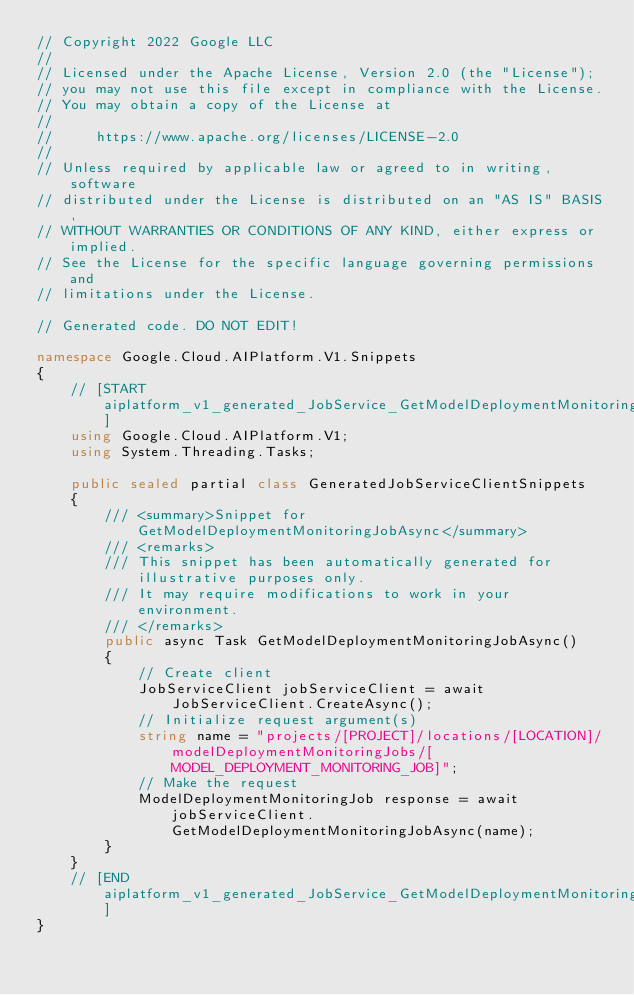Convert code to text. <code><loc_0><loc_0><loc_500><loc_500><_C#_>// Copyright 2022 Google LLC
//
// Licensed under the Apache License, Version 2.0 (the "License");
// you may not use this file except in compliance with the License.
// You may obtain a copy of the License at
//
//     https://www.apache.org/licenses/LICENSE-2.0
//
// Unless required by applicable law or agreed to in writing, software
// distributed under the License is distributed on an "AS IS" BASIS,
// WITHOUT WARRANTIES OR CONDITIONS OF ANY KIND, either express or implied.
// See the License for the specific language governing permissions and
// limitations under the License.

// Generated code. DO NOT EDIT!

namespace Google.Cloud.AIPlatform.V1.Snippets
{
    // [START aiplatform_v1_generated_JobService_GetModelDeploymentMonitoringJob_async_flattened]
    using Google.Cloud.AIPlatform.V1;
    using System.Threading.Tasks;

    public sealed partial class GeneratedJobServiceClientSnippets
    {
        /// <summary>Snippet for GetModelDeploymentMonitoringJobAsync</summary>
        /// <remarks>
        /// This snippet has been automatically generated for illustrative purposes only.
        /// It may require modifications to work in your environment.
        /// </remarks>
        public async Task GetModelDeploymentMonitoringJobAsync()
        {
            // Create client
            JobServiceClient jobServiceClient = await JobServiceClient.CreateAsync();
            // Initialize request argument(s)
            string name = "projects/[PROJECT]/locations/[LOCATION]/modelDeploymentMonitoringJobs/[MODEL_DEPLOYMENT_MONITORING_JOB]";
            // Make the request
            ModelDeploymentMonitoringJob response = await jobServiceClient.GetModelDeploymentMonitoringJobAsync(name);
        }
    }
    // [END aiplatform_v1_generated_JobService_GetModelDeploymentMonitoringJob_async_flattened]
}
</code> 